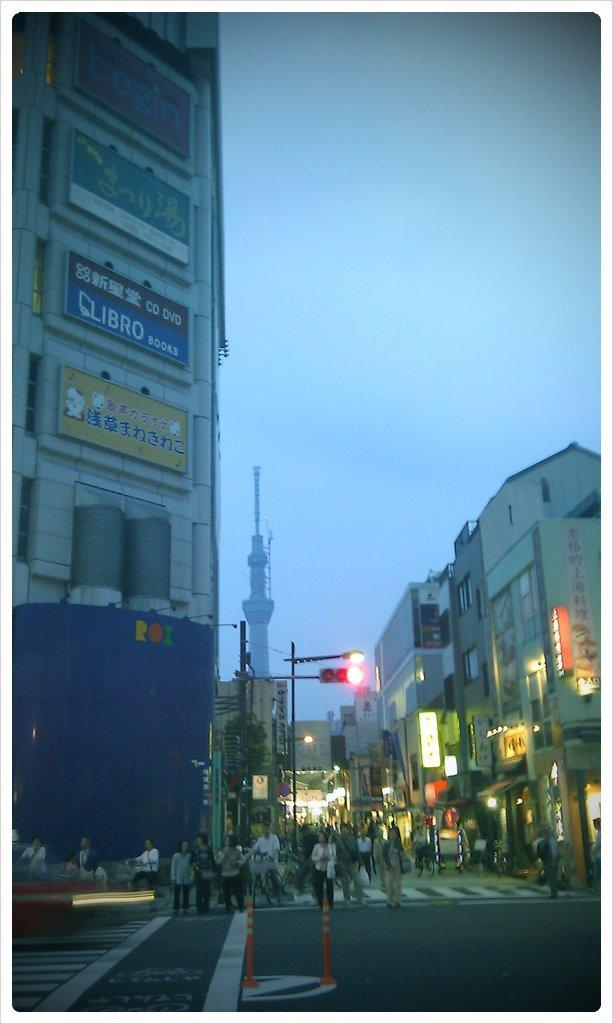What type of structures can be seen in the image? There are buildings in the image. Can you describe the people in the image? There is a group of people in the image. What can be seen in the background of the image? In the background of the image, there are poles, traffic lights, hoardings, and lights. What type of crime is being committed in the image? There is no indication of any crime being committed in the image. 